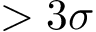<formula> <loc_0><loc_0><loc_500><loc_500>> 3 \sigma</formula> 